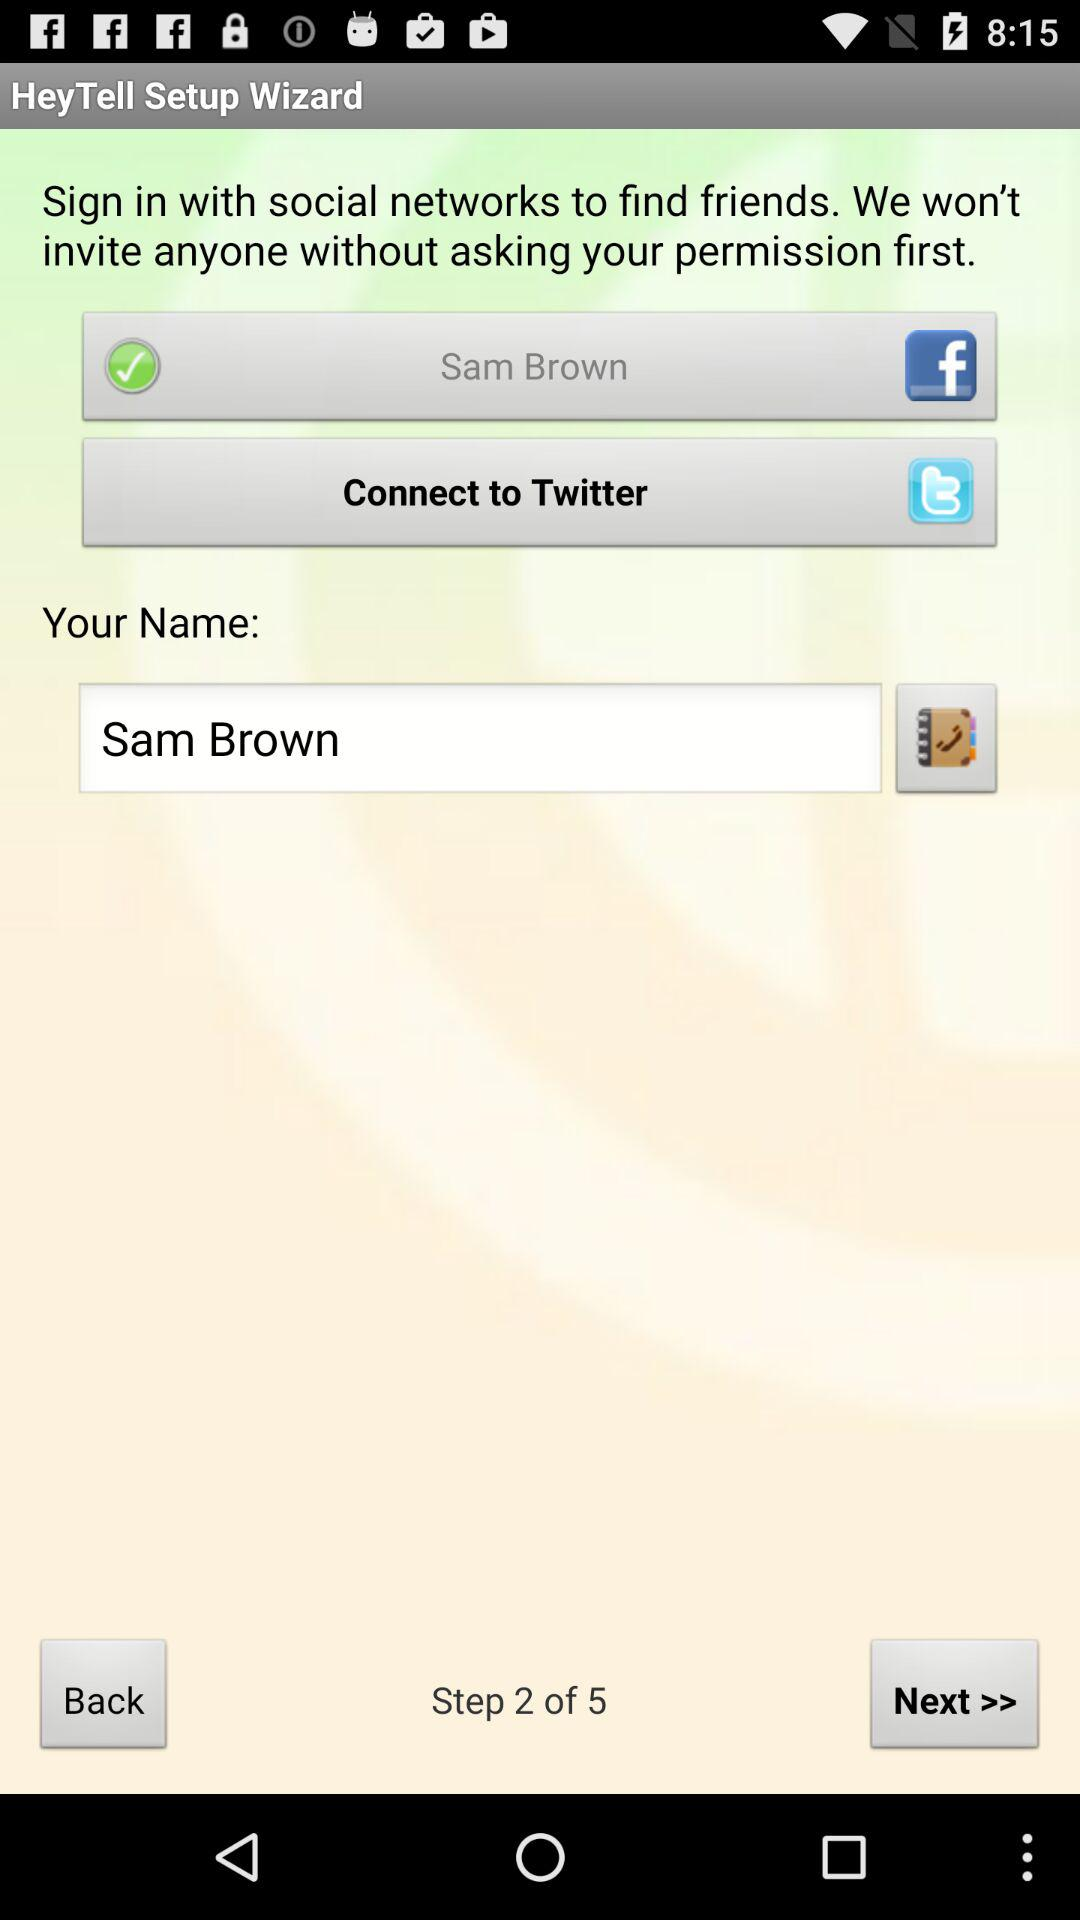How many steps are there? There are 5 steps. 